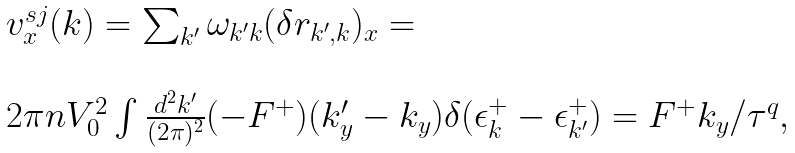<formula> <loc_0><loc_0><loc_500><loc_500>\begin{array} { l } v _ { x } ^ { s j } ( { k } ) = \sum _ { k ^ { \prime } } \omega _ { k ^ { \prime } k } ( \delta { r } _ { k ^ { \prime } , k } ) _ { x } = \\ \\ 2 \pi n V _ { 0 } ^ { 2 } \int \frac { d ^ { 2 } { k ^ { \prime } } } { ( 2 \pi ) ^ { 2 } } ( - F ^ { + } ) ( k _ { y } ^ { \prime } - k _ { y } ) \delta ( \epsilon _ { k } ^ { + } - \epsilon ^ { + } _ { k ^ { \prime } } ) = F ^ { + } k _ { y } / \tau ^ { q } , \end{array}</formula> 